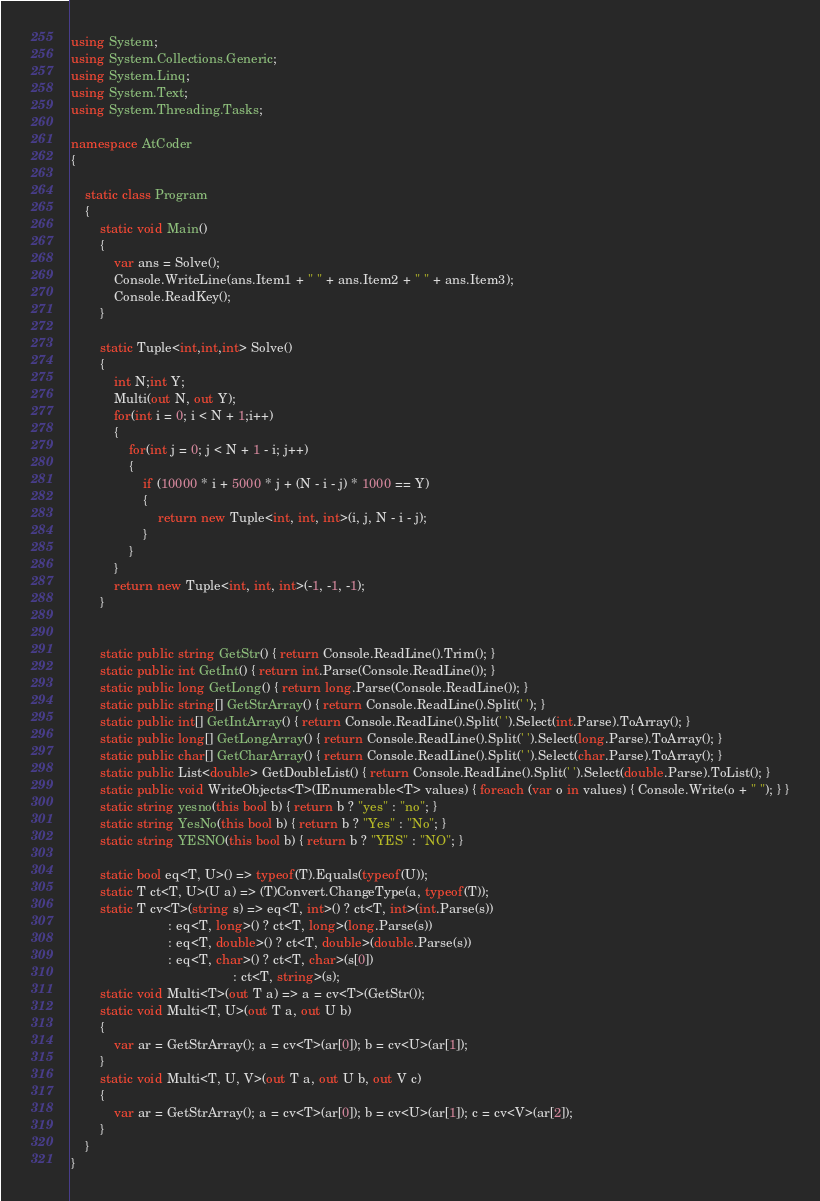Convert code to text. <code><loc_0><loc_0><loc_500><loc_500><_C#_>using System;
using System.Collections.Generic;
using System.Linq;
using System.Text;
using System.Threading.Tasks;

namespace AtCoder
{

    static class Program
    {
        static void Main()
        {
            var ans = Solve();
            Console.WriteLine(ans.Item1 + " " + ans.Item2 + " " + ans.Item3);
            Console.ReadKey();
        }

        static Tuple<int,int,int> Solve()
        {
            int N;int Y;
            Multi(out N, out Y);
            for(int i = 0; i < N + 1;i++)
            {
                for(int j = 0; j < N + 1 - i; j++)
                {
                    if (10000 * i + 5000 * j + (N - i - j) * 1000 == Y)
                    {
                        return new Tuple<int, int, int>(i, j, N - i - j);
                    }
                }
            }
            return new Tuple<int, int, int>(-1, -1, -1);
        }


        static public string GetStr() { return Console.ReadLine().Trim(); }
        static public int GetInt() { return int.Parse(Console.ReadLine()); }
        static public long GetLong() { return long.Parse(Console.ReadLine()); }
        static public string[] GetStrArray() { return Console.ReadLine().Split(' '); }
        static public int[] GetIntArray() { return Console.ReadLine().Split(' ').Select(int.Parse).ToArray(); }
        static public long[] GetLongArray() { return Console.ReadLine().Split(' ').Select(long.Parse).ToArray(); }
        static public char[] GetCharArray() { return Console.ReadLine().Split(' ').Select(char.Parse).ToArray(); }
        static public List<double> GetDoubleList() { return Console.ReadLine().Split(' ').Select(double.Parse).ToList(); }
        static public void WriteObjects<T>(IEnumerable<T> values) { foreach (var o in values) { Console.Write(o + " "); } }
        static string yesno(this bool b) { return b ? "yes" : "no"; }
        static string YesNo(this bool b) { return b ? "Yes" : "No"; }
        static string YESNO(this bool b) { return b ? "YES" : "NO"; }

        static bool eq<T, U>() => typeof(T).Equals(typeof(U));
        static T ct<T, U>(U a) => (T)Convert.ChangeType(a, typeof(T));
        static T cv<T>(string s) => eq<T, int>() ? ct<T, int>(int.Parse(s))
                           : eq<T, long>() ? ct<T, long>(long.Parse(s))
                           : eq<T, double>() ? ct<T, double>(double.Parse(s))
                           : eq<T, char>() ? ct<T, char>(s[0])
                                             : ct<T, string>(s);
        static void Multi<T>(out T a) => a = cv<T>(GetStr());
        static void Multi<T, U>(out T a, out U b)
        {
            var ar = GetStrArray(); a = cv<T>(ar[0]); b = cv<U>(ar[1]);
        }
        static void Multi<T, U, V>(out T a, out U b, out V c)
        {
            var ar = GetStrArray(); a = cv<T>(ar[0]); b = cv<U>(ar[1]); c = cv<V>(ar[2]);
        }
    }
}</code> 